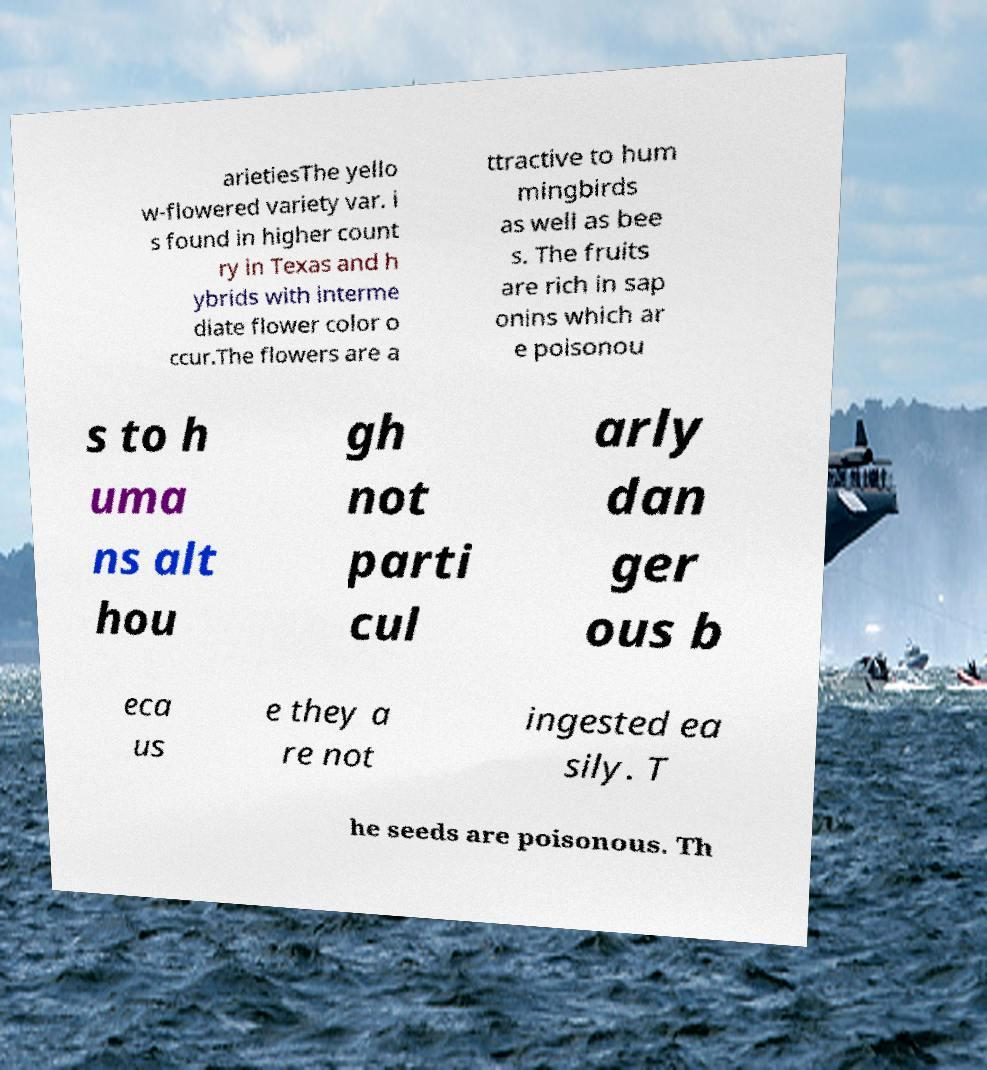For documentation purposes, I need the text within this image transcribed. Could you provide that? arietiesThe yello w-flowered variety var. i s found in higher count ry in Texas and h ybrids with interme diate flower color o ccur.The flowers are a ttractive to hum mingbirds as well as bee s. The fruits are rich in sap onins which ar e poisonou s to h uma ns alt hou gh not parti cul arly dan ger ous b eca us e they a re not ingested ea sily. T he seeds are poisonous. Th 